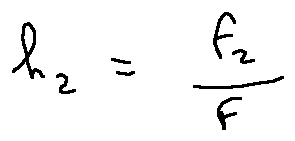Convert formula to latex. <formula><loc_0><loc_0><loc_500><loc_500>h _ { 2 } = \frac { f _ { 2 } } { f }</formula> 